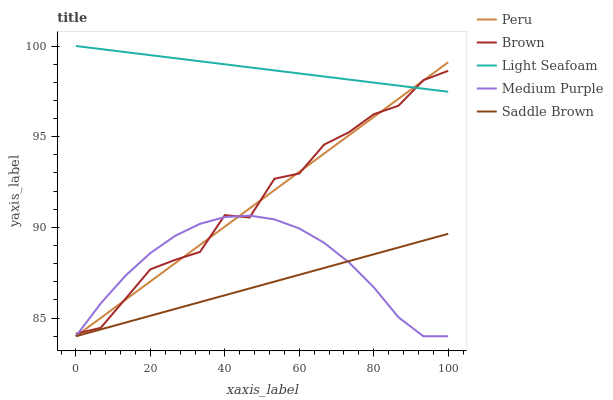Does Saddle Brown have the minimum area under the curve?
Answer yes or no. Yes. Does Light Seafoam have the maximum area under the curve?
Answer yes or no. Yes. Does Brown have the minimum area under the curve?
Answer yes or no. No. Does Brown have the maximum area under the curve?
Answer yes or no. No. Is Saddle Brown the smoothest?
Answer yes or no. Yes. Is Brown the roughest?
Answer yes or no. Yes. Is Light Seafoam the smoothest?
Answer yes or no. No. Is Light Seafoam the roughest?
Answer yes or no. No. Does Medium Purple have the lowest value?
Answer yes or no. Yes. Does Brown have the lowest value?
Answer yes or no. No. Does Light Seafoam have the highest value?
Answer yes or no. Yes. Does Brown have the highest value?
Answer yes or no. No. Is Medium Purple less than Light Seafoam?
Answer yes or no. Yes. Is Light Seafoam greater than Saddle Brown?
Answer yes or no. Yes. Does Brown intersect Light Seafoam?
Answer yes or no. Yes. Is Brown less than Light Seafoam?
Answer yes or no. No. Is Brown greater than Light Seafoam?
Answer yes or no. No. Does Medium Purple intersect Light Seafoam?
Answer yes or no. No. 